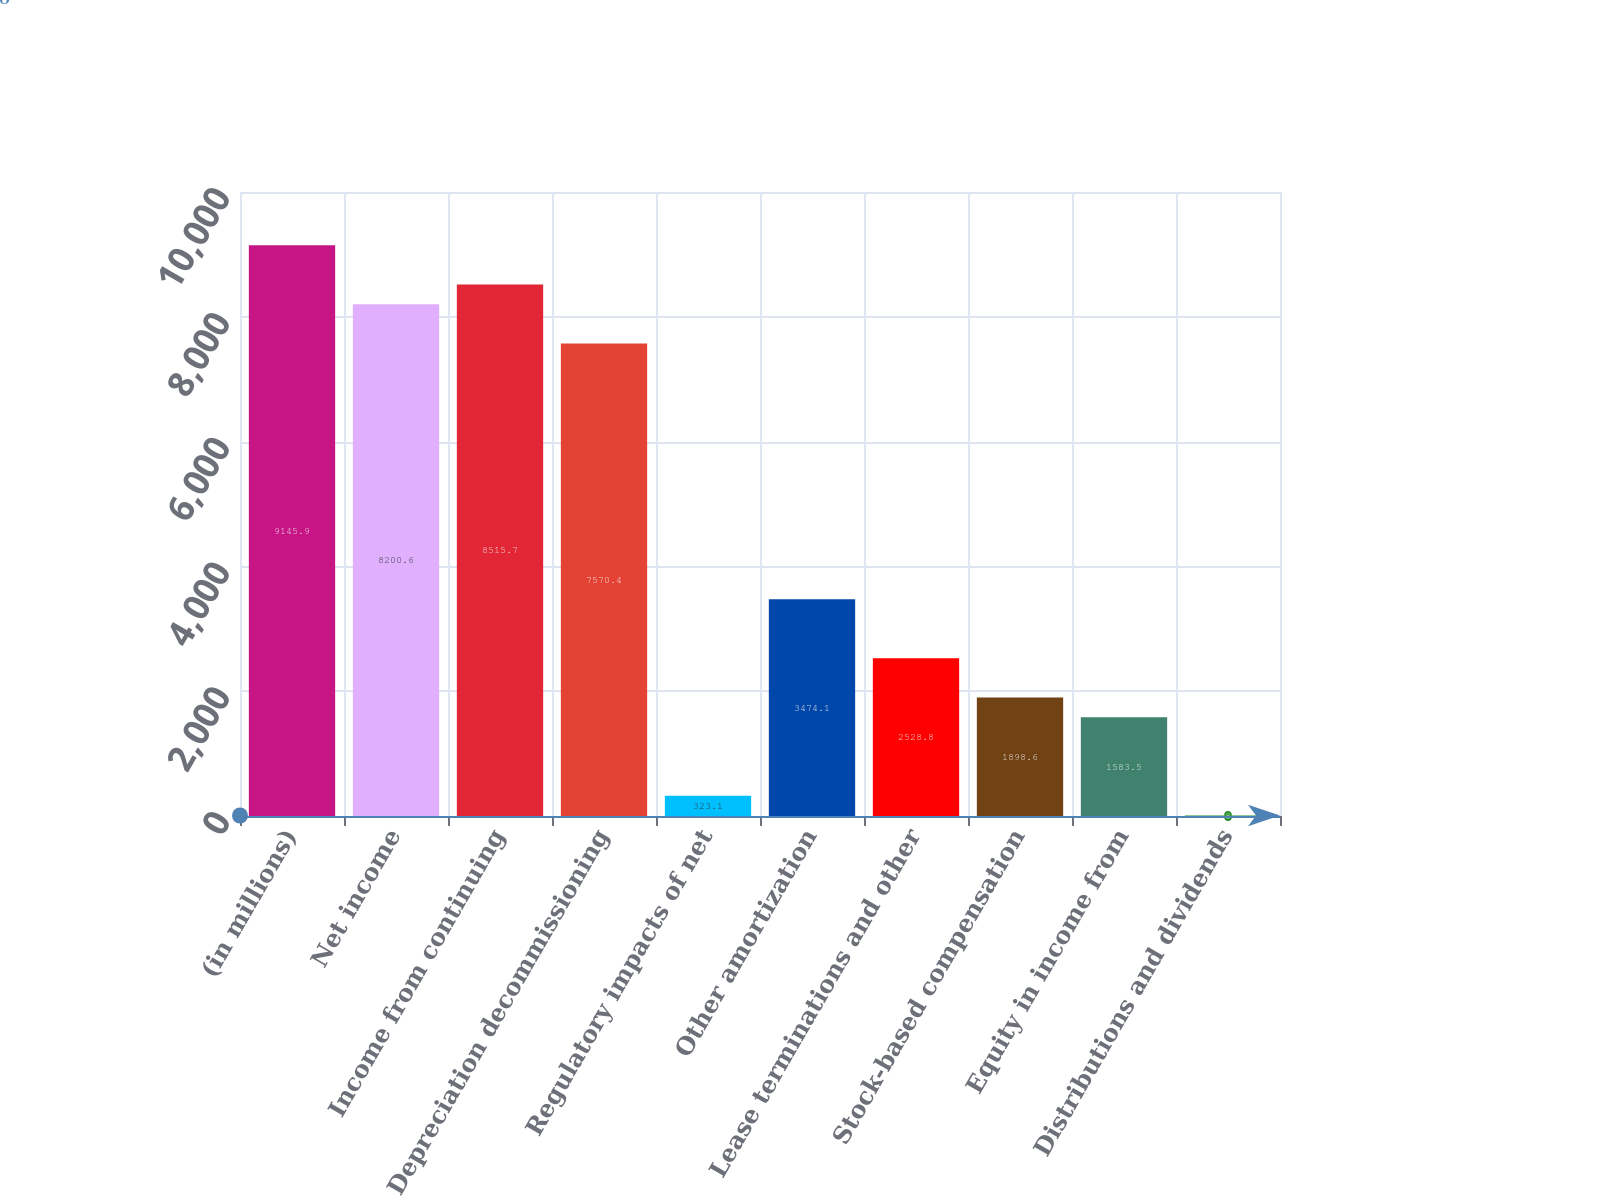<chart> <loc_0><loc_0><loc_500><loc_500><bar_chart><fcel>(in millions)<fcel>Net income<fcel>Income from continuing<fcel>Depreciation decommissioning<fcel>Regulatory impacts of net<fcel>Other amortization<fcel>Lease terminations and other<fcel>Stock-based compensation<fcel>Equity in income from<fcel>Distributions and dividends<nl><fcel>9145.9<fcel>8200.6<fcel>8515.7<fcel>7570.4<fcel>323.1<fcel>3474.1<fcel>2528.8<fcel>1898.6<fcel>1583.5<fcel>8<nl></chart> 